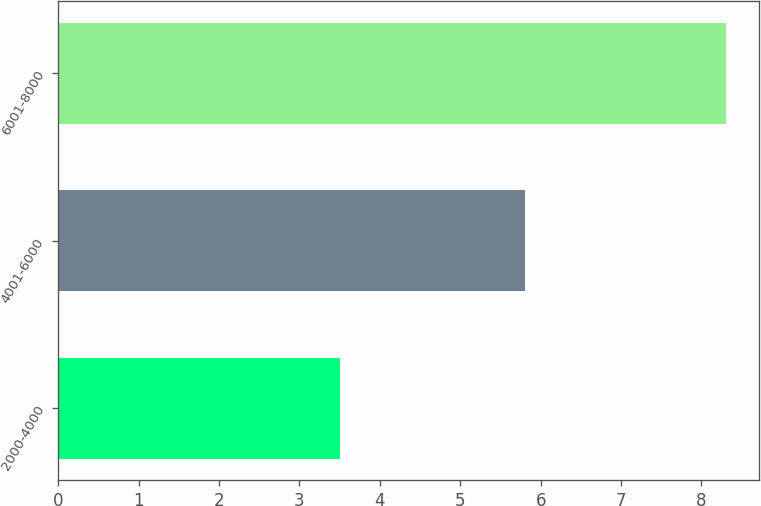<chart> <loc_0><loc_0><loc_500><loc_500><bar_chart><fcel>2000-4000<fcel>4001-6000<fcel>6001-8000<nl><fcel>3.5<fcel>5.8<fcel>8.3<nl></chart> 